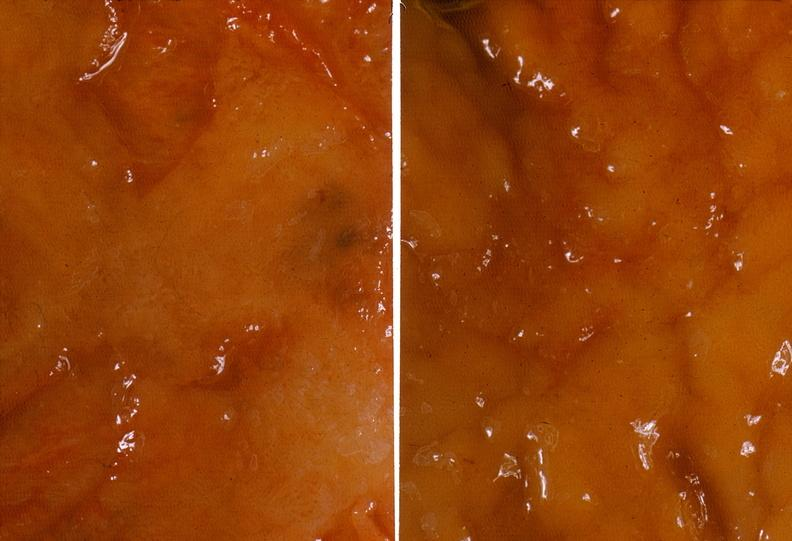does this image show colon, ulcerative colitis, mucosal detail?
Answer the question using a single word or phrase. Yes 